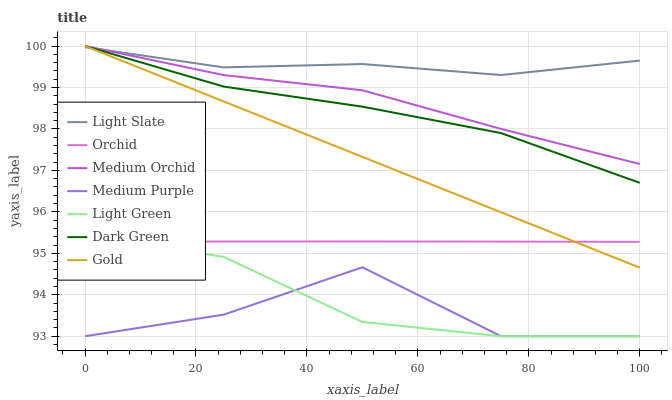Does Medium Purple have the minimum area under the curve?
Answer yes or no. Yes. Does Light Slate have the maximum area under the curve?
Answer yes or no. Yes. Does Medium Orchid have the minimum area under the curve?
Answer yes or no. No. Does Medium Orchid have the maximum area under the curve?
Answer yes or no. No. Is Gold the smoothest?
Answer yes or no. Yes. Is Medium Purple the roughest?
Answer yes or no. Yes. Is Light Slate the smoothest?
Answer yes or no. No. Is Light Slate the roughest?
Answer yes or no. No. Does Medium Purple have the lowest value?
Answer yes or no. Yes. Does Medium Orchid have the lowest value?
Answer yes or no. No. Does Dark Green have the highest value?
Answer yes or no. Yes. Does Light Slate have the highest value?
Answer yes or no. No. Is Light Green less than Light Slate?
Answer yes or no. Yes. Is Medium Orchid greater than Orchid?
Answer yes or no. Yes. Does Dark Green intersect Medium Orchid?
Answer yes or no. Yes. Is Dark Green less than Medium Orchid?
Answer yes or no. No. Is Dark Green greater than Medium Orchid?
Answer yes or no. No. Does Light Green intersect Light Slate?
Answer yes or no. No. 